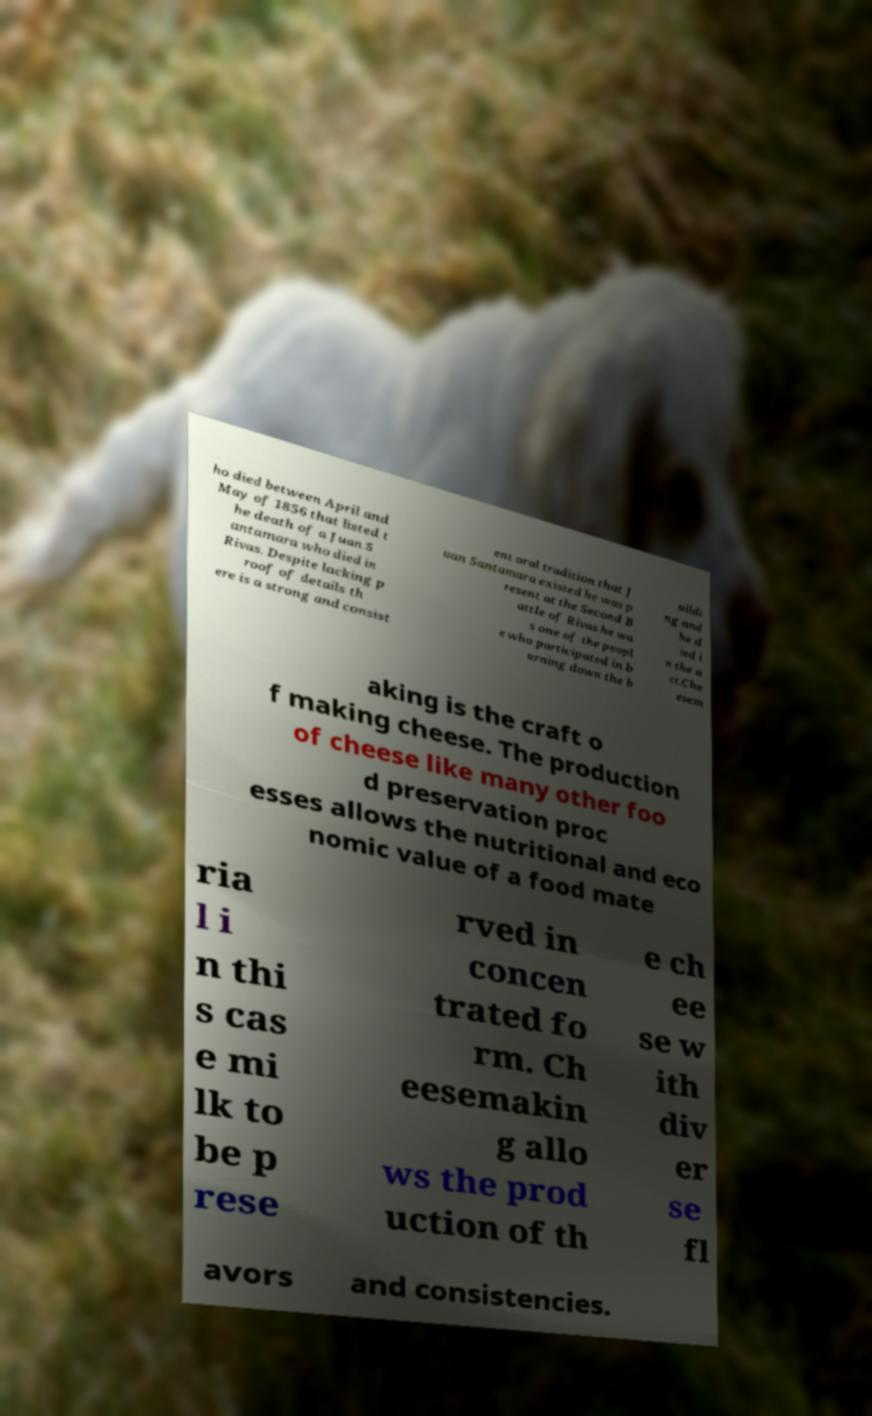Can you read and provide the text displayed in the image?This photo seems to have some interesting text. Can you extract and type it out for me? ho died between April and May of 1856 that listed t he death of a Juan S antamara who died in Rivas. Despite lacking p roof of details th ere is a strong and consist ent oral tradition that J uan Santamara existed he was p resent at the Second B attle of Rivas he wa s one of the peopl e who participated in b urning down the b uildi ng and he d ied i n the a ct.Che esem aking is the craft o f making cheese. The production of cheese like many other foo d preservation proc esses allows the nutritional and eco nomic value of a food mate ria l i n thi s cas e mi lk to be p rese rved in concen trated fo rm. Ch eesemakin g allo ws the prod uction of th e ch ee se w ith div er se fl avors and consistencies. 